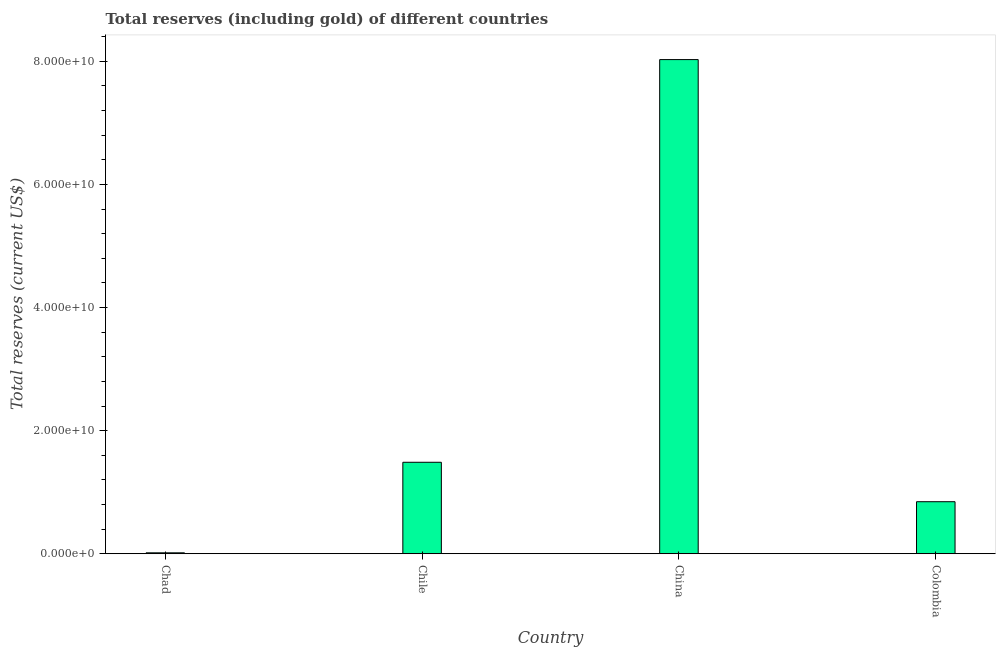What is the title of the graph?
Your answer should be compact. Total reserves (including gold) of different countries. What is the label or title of the Y-axis?
Offer a terse response. Total reserves (current US$). What is the total reserves (including gold) in Chile?
Make the answer very short. 1.49e+1. Across all countries, what is the maximum total reserves (including gold)?
Offer a very short reply. 8.03e+1. Across all countries, what is the minimum total reserves (including gold)?
Offer a very short reply. 1.47e+08. In which country was the total reserves (including gold) minimum?
Offer a very short reply. Chad. What is the sum of the total reserves (including gold)?
Your answer should be compact. 1.04e+11. What is the difference between the total reserves (including gold) in Chile and Colombia?
Your answer should be compact. 6.41e+09. What is the average total reserves (including gold) per country?
Make the answer very short. 2.59e+1. What is the median total reserves (including gold)?
Your answer should be very brief. 1.17e+1. In how many countries, is the total reserves (including gold) greater than 56000000000 US$?
Keep it short and to the point. 1. What is the ratio of the total reserves (including gold) in Chad to that in Chile?
Ensure brevity in your answer.  0.01. Is the total reserves (including gold) in Chad less than that in China?
Provide a short and direct response. Yes. Is the difference between the total reserves (including gold) in Chile and Colombia greater than the difference between any two countries?
Provide a short and direct response. No. What is the difference between the highest and the second highest total reserves (including gold)?
Give a very brief answer. 6.54e+1. Is the sum of the total reserves (including gold) in China and Colombia greater than the maximum total reserves (including gold) across all countries?
Make the answer very short. Yes. What is the difference between the highest and the lowest total reserves (including gold)?
Your answer should be very brief. 8.01e+1. How many bars are there?
Your answer should be compact. 4. How many countries are there in the graph?
Offer a terse response. 4. What is the difference between two consecutive major ticks on the Y-axis?
Your answer should be compact. 2.00e+1. Are the values on the major ticks of Y-axis written in scientific E-notation?
Your answer should be very brief. Yes. What is the Total reserves (current US$) of Chad?
Your answer should be compact. 1.47e+08. What is the Total reserves (current US$) of Chile?
Give a very brief answer. 1.49e+1. What is the Total reserves (current US$) in China?
Give a very brief answer. 8.03e+1. What is the Total reserves (current US$) of Colombia?
Offer a terse response. 8.45e+09. What is the difference between the Total reserves (current US$) in Chad and Chile?
Your answer should be very brief. -1.47e+1. What is the difference between the Total reserves (current US$) in Chad and China?
Give a very brief answer. -8.01e+1. What is the difference between the Total reserves (current US$) in Chad and Colombia?
Ensure brevity in your answer.  -8.31e+09. What is the difference between the Total reserves (current US$) in Chile and China?
Ensure brevity in your answer.  -6.54e+1. What is the difference between the Total reserves (current US$) in Chile and Colombia?
Provide a succinct answer. 6.41e+09. What is the difference between the Total reserves (current US$) in China and Colombia?
Keep it short and to the point. 7.18e+1. What is the ratio of the Total reserves (current US$) in Chad to that in Chile?
Ensure brevity in your answer.  0.01. What is the ratio of the Total reserves (current US$) in Chad to that in China?
Your response must be concise. 0. What is the ratio of the Total reserves (current US$) in Chad to that in Colombia?
Keep it short and to the point. 0.02. What is the ratio of the Total reserves (current US$) in Chile to that in China?
Offer a very short reply. 0.18. What is the ratio of the Total reserves (current US$) in Chile to that in Colombia?
Offer a very short reply. 1.76. What is the ratio of the Total reserves (current US$) in China to that in Colombia?
Make the answer very short. 9.5. 